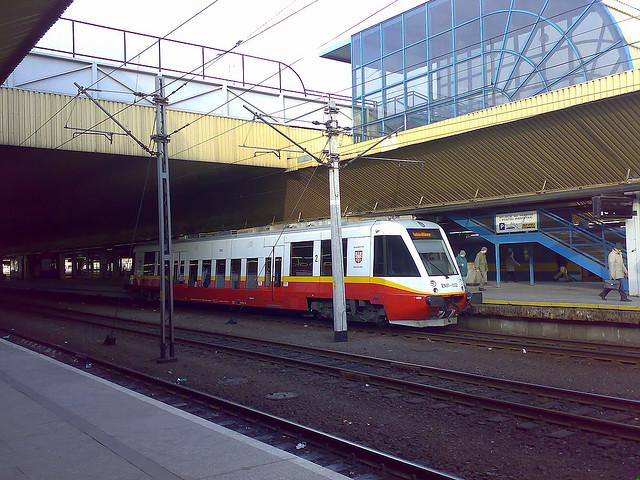What are the wires above the train used for?

Choices:
A) climbing
B) hanging
C) decoration
D) power power 